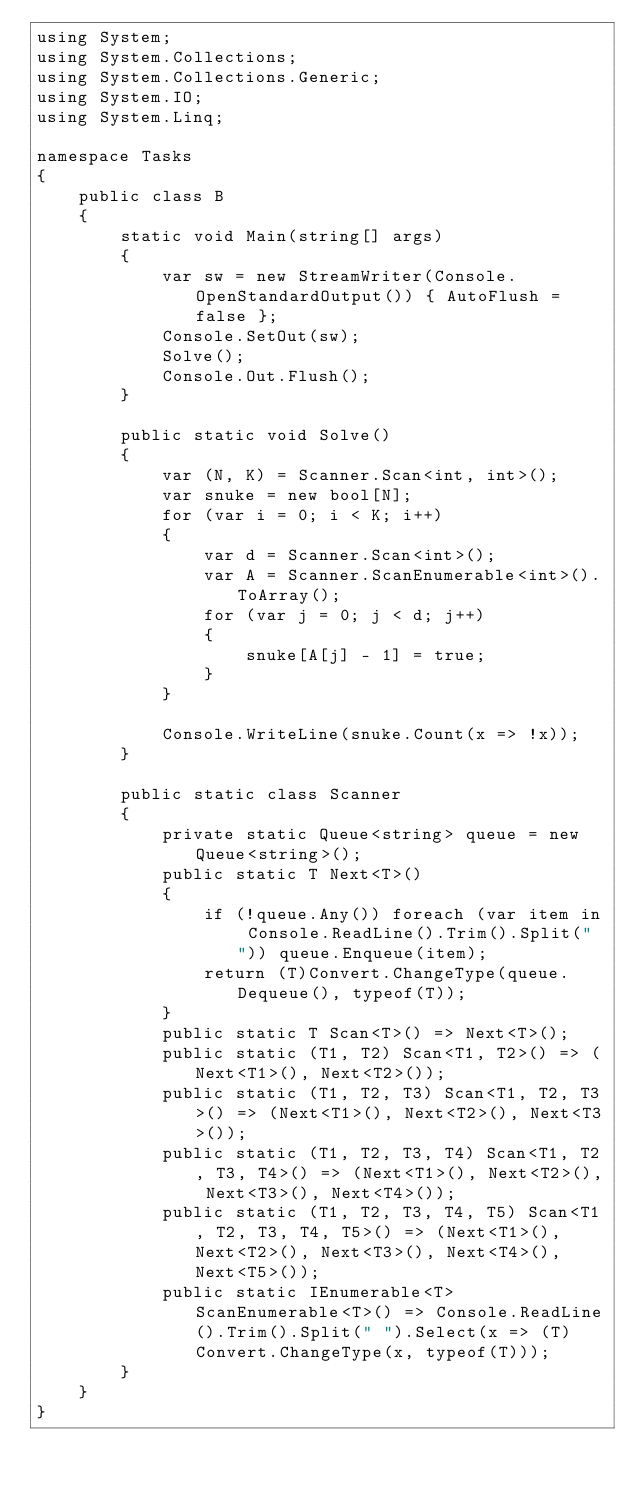Convert code to text. <code><loc_0><loc_0><loc_500><loc_500><_C#_>using System;
using System.Collections;
using System.Collections.Generic;
using System.IO;
using System.Linq;

namespace Tasks
{
    public class B
    {
        static void Main(string[] args)
        {
            var sw = new StreamWriter(Console.OpenStandardOutput()) { AutoFlush = false };
            Console.SetOut(sw);
            Solve();
            Console.Out.Flush();
        }

        public static void Solve()
        {
            var (N, K) = Scanner.Scan<int, int>();
            var snuke = new bool[N];
            for (var i = 0; i < K; i++)
            {
                var d = Scanner.Scan<int>();
                var A = Scanner.ScanEnumerable<int>().ToArray();
                for (var j = 0; j < d; j++)
                {
                    snuke[A[j] - 1] = true;
                }
            }

            Console.WriteLine(snuke.Count(x => !x));
        }

        public static class Scanner
        {
            private static Queue<string> queue = new Queue<string>();
            public static T Next<T>()
            {
                if (!queue.Any()) foreach (var item in Console.ReadLine().Trim().Split(" ")) queue.Enqueue(item);
                return (T)Convert.ChangeType(queue.Dequeue(), typeof(T));
            }
            public static T Scan<T>() => Next<T>();
            public static (T1, T2) Scan<T1, T2>() => (Next<T1>(), Next<T2>());
            public static (T1, T2, T3) Scan<T1, T2, T3>() => (Next<T1>(), Next<T2>(), Next<T3>());
            public static (T1, T2, T3, T4) Scan<T1, T2, T3, T4>() => (Next<T1>(), Next<T2>(), Next<T3>(), Next<T4>());
            public static (T1, T2, T3, T4, T5) Scan<T1, T2, T3, T4, T5>() => (Next<T1>(), Next<T2>(), Next<T3>(), Next<T4>(), Next<T5>());
            public static IEnumerable<T> ScanEnumerable<T>() => Console.ReadLine().Trim().Split(" ").Select(x => (T)Convert.ChangeType(x, typeof(T)));
        }
    }
}
</code> 